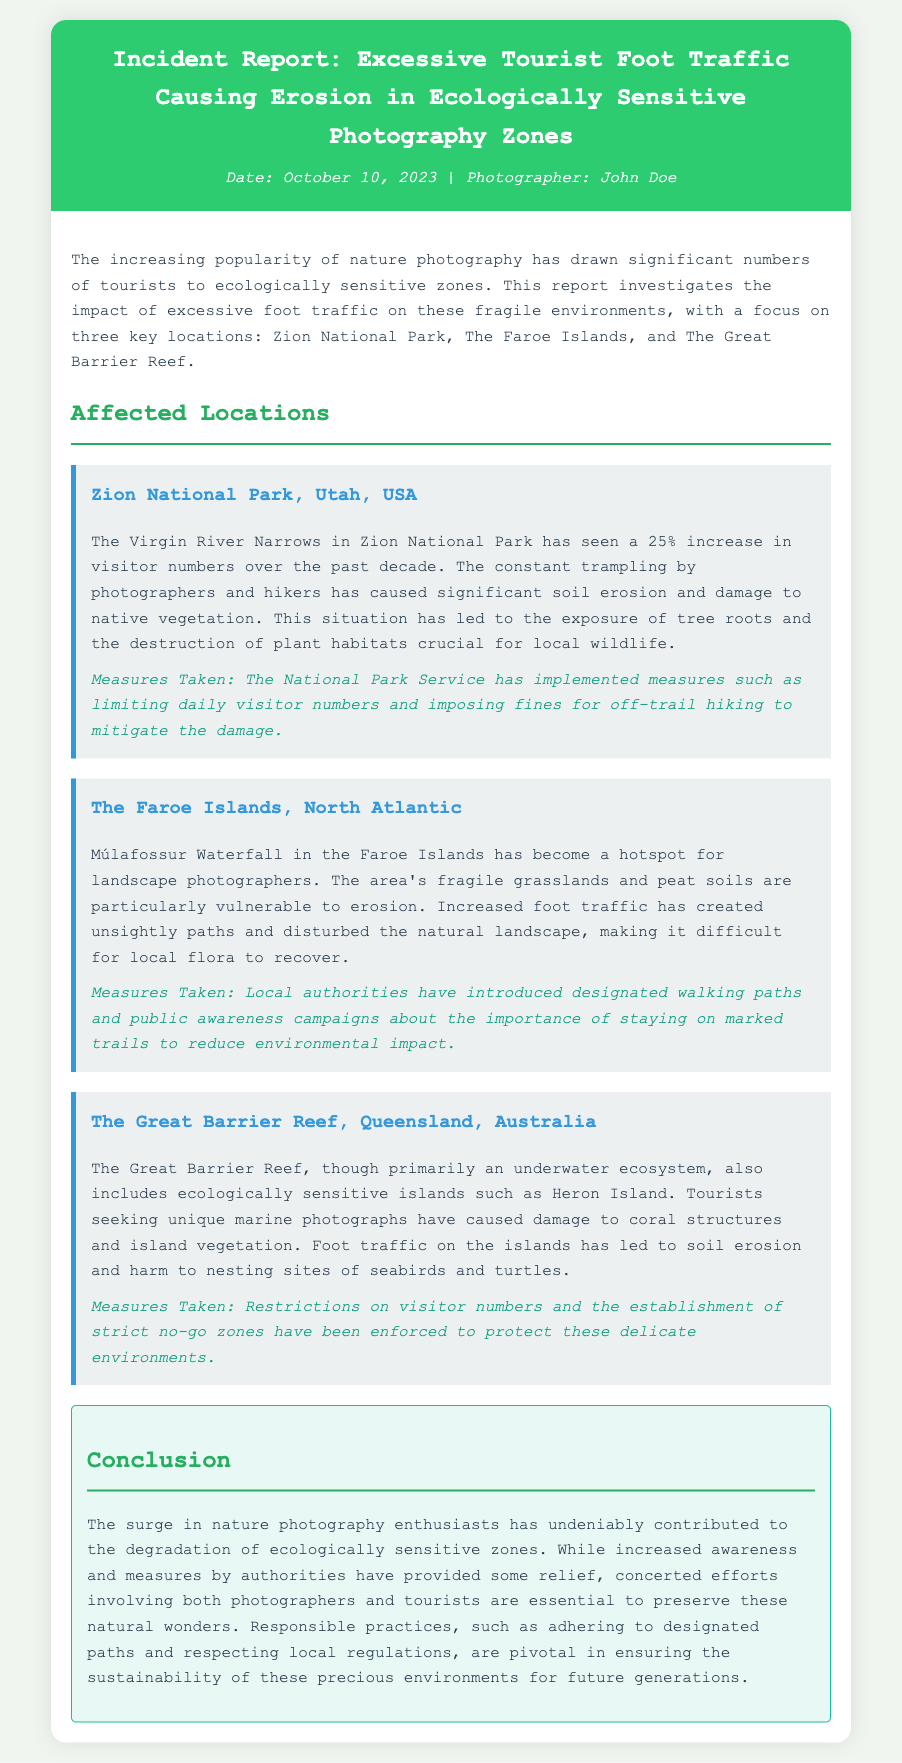What is the date of the incident report? The date of the incident report is provided at the top of the document.
Answer: October 10, 2023 Who is the photographer mentioned in the report? The photographer's name is listed in the header of the document.
Answer: John Doe What is the percentage increase in visitor numbers at Zion National Park? The report states the increase in visitor numbers as a percentage.
Answer: 25% What measures have been taken in the Faroe Islands? The measures taken are mentioned under the observation for the Faroe Islands.
Answer: Designated walking paths What type of vegetation is harmed at The Great Barrier Reef? The document specifies the type of harm caused to vegetation in the Great Barrier Reef section.
Answer: Coral structures What is the conclusion regarding the impact of photography tourism? The conclusion summarizes the effects mentioned throughout the report.
Answer: Degradation of ecologically sensitive zones How many ecologically sensitive locations are discussed in the document? The total locations covered in the report can be counted from the sections.
Answer: Three What specific areas have been affected by tourist foot traffic in Zion National Park? The report highlights the specific area affected by visitor foot traffic.
Answer: Virgin River Narrows What is the ecological impact mentioned for Múlafossur Waterfall? The ecological impact is described in the observation for the Faroe Islands.
Answer: Erosion 